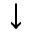<formula> <loc_0><loc_0><loc_500><loc_500>\downarrow</formula> 